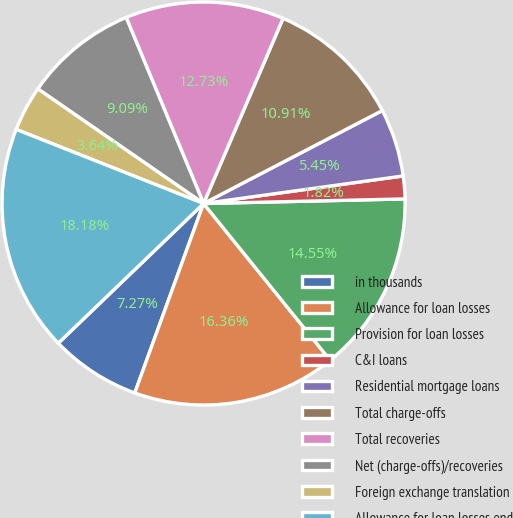<chart> <loc_0><loc_0><loc_500><loc_500><pie_chart><fcel>in thousands<fcel>Allowance for loan losses<fcel>Provision for loan losses<fcel>C&I loans<fcel>Residential mortgage loans<fcel>Total charge-offs<fcel>Total recoveries<fcel>Net (charge-offs)/recoveries<fcel>Foreign exchange translation<fcel>Allowance for loan losses end<nl><fcel>7.27%<fcel>16.36%<fcel>14.55%<fcel>1.82%<fcel>5.45%<fcel>10.91%<fcel>12.73%<fcel>9.09%<fcel>3.64%<fcel>18.18%<nl></chart> 